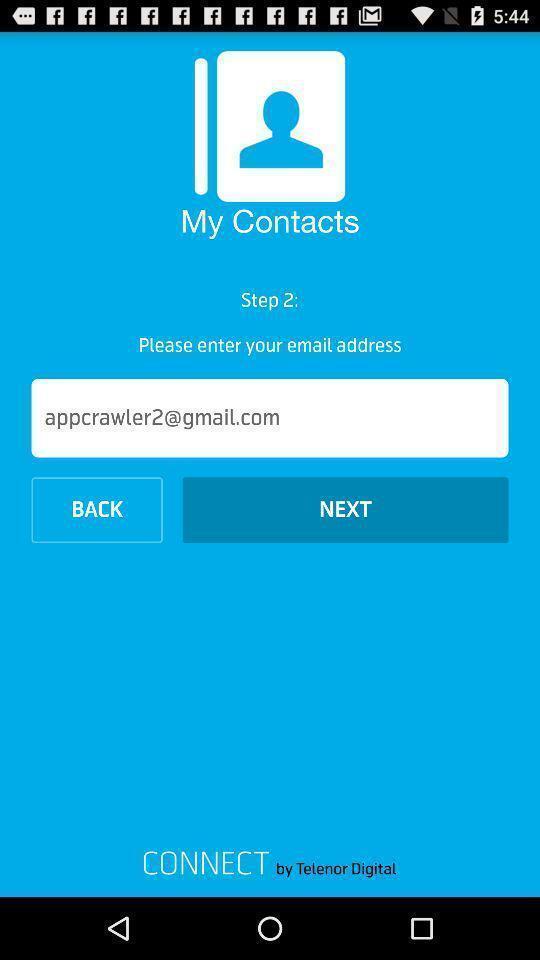Explain the elements present in this screenshot. Page to enter email address for contact app. 